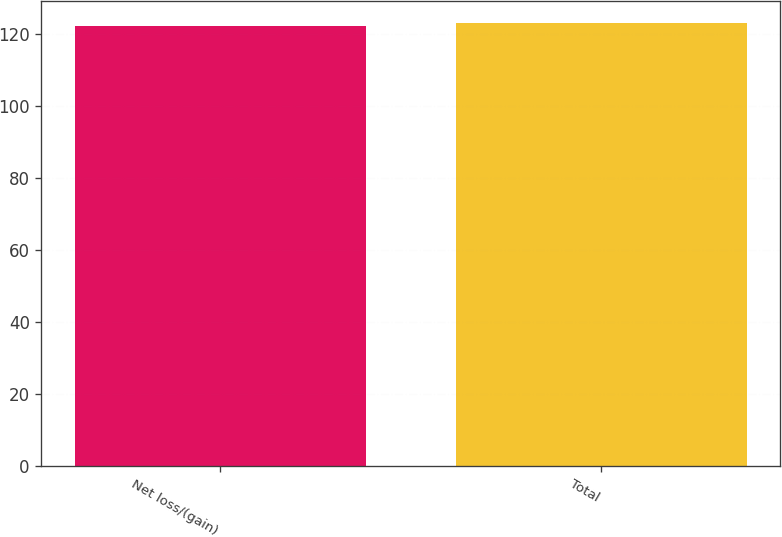Convert chart. <chart><loc_0><loc_0><loc_500><loc_500><bar_chart><fcel>Net loss/(gain)<fcel>Total<nl><fcel>122<fcel>123<nl></chart> 